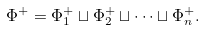Convert formula to latex. <formula><loc_0><loc_0><loc_500><loc_500>\Phi ^ { + } = \Phi _ { 1 } ^ { + } \sqcup \Phi _ { 2 } ^ { + } \sqcup \cdots \sqcup \Phi _ { n } ^ { + } .</formula> 